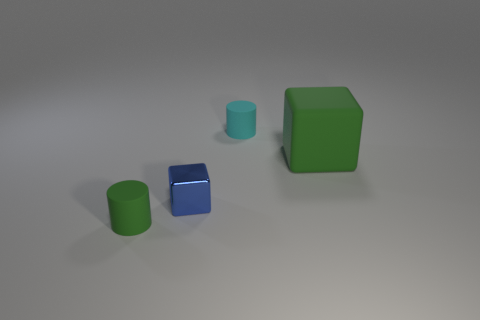There is a thing that is both behind the tiny blue metallic thing and in front of the small cyan rubber cylinder; what is its material?
Give a very brief answer. Rubber. There is a small thing behind the green block; is its shape the same as the small green rubber thing?
Keep it short and to the point. Yes. Is the number of rubber cylinders less than the number of tiny green matte cylinders?
Give a very brief answer. No. How many rubber cylinders are the same color as the tiny cube?
Offer a very short reply. 0. There is a big cube; does it have the same color as the rubber object to the left of the small block?
Your response must be concise. Yes. Is the number of cylinders greater than the number of large matte things?
Offer a very short reply. Yes. What size is the green thing that is the same shape as the blue shiny thing?
Ensure brevity in your answer.  Large. Do the green cylinder and the cube left of the tiny cyan cylinder have the same material?
Make the answer very short. No. What number of objects are small blue things or cylinders?
Offer a very short reply. 3. Is the size of the green thing that is on the left side of the tiny cyan cylinder the same as the green object that is behind the metal object?
Make the answer very short. No. 